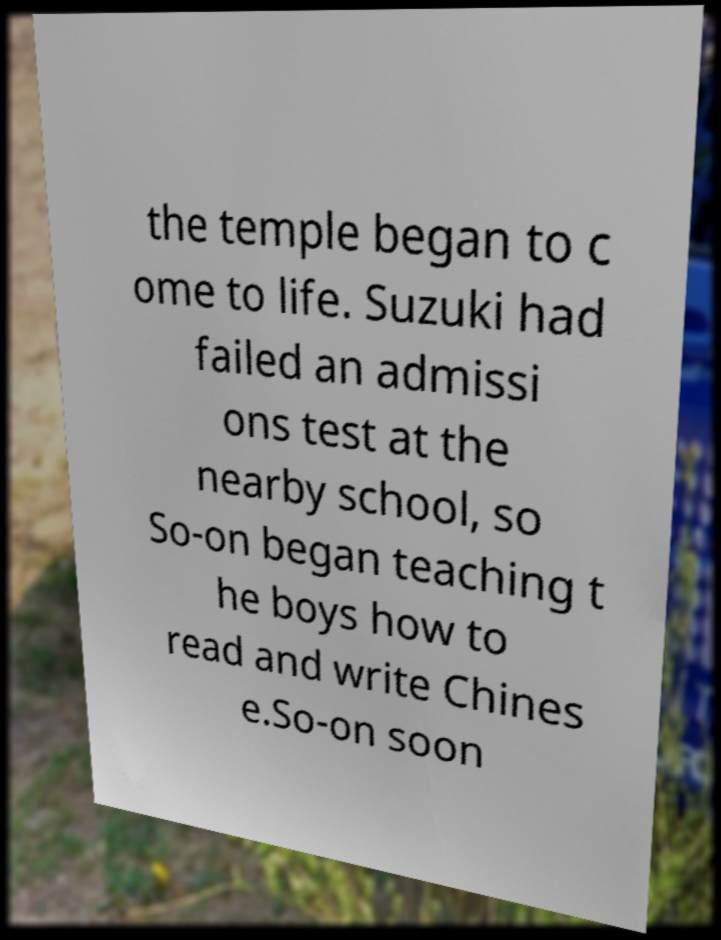Can you accurately transcribe the text from the provided image for me? the temple began to c ome to life. Suzuki had failed an admissi ons test at the nearby school, so So-on began teaching t he boys how to read and write Chines e.So-on soon 